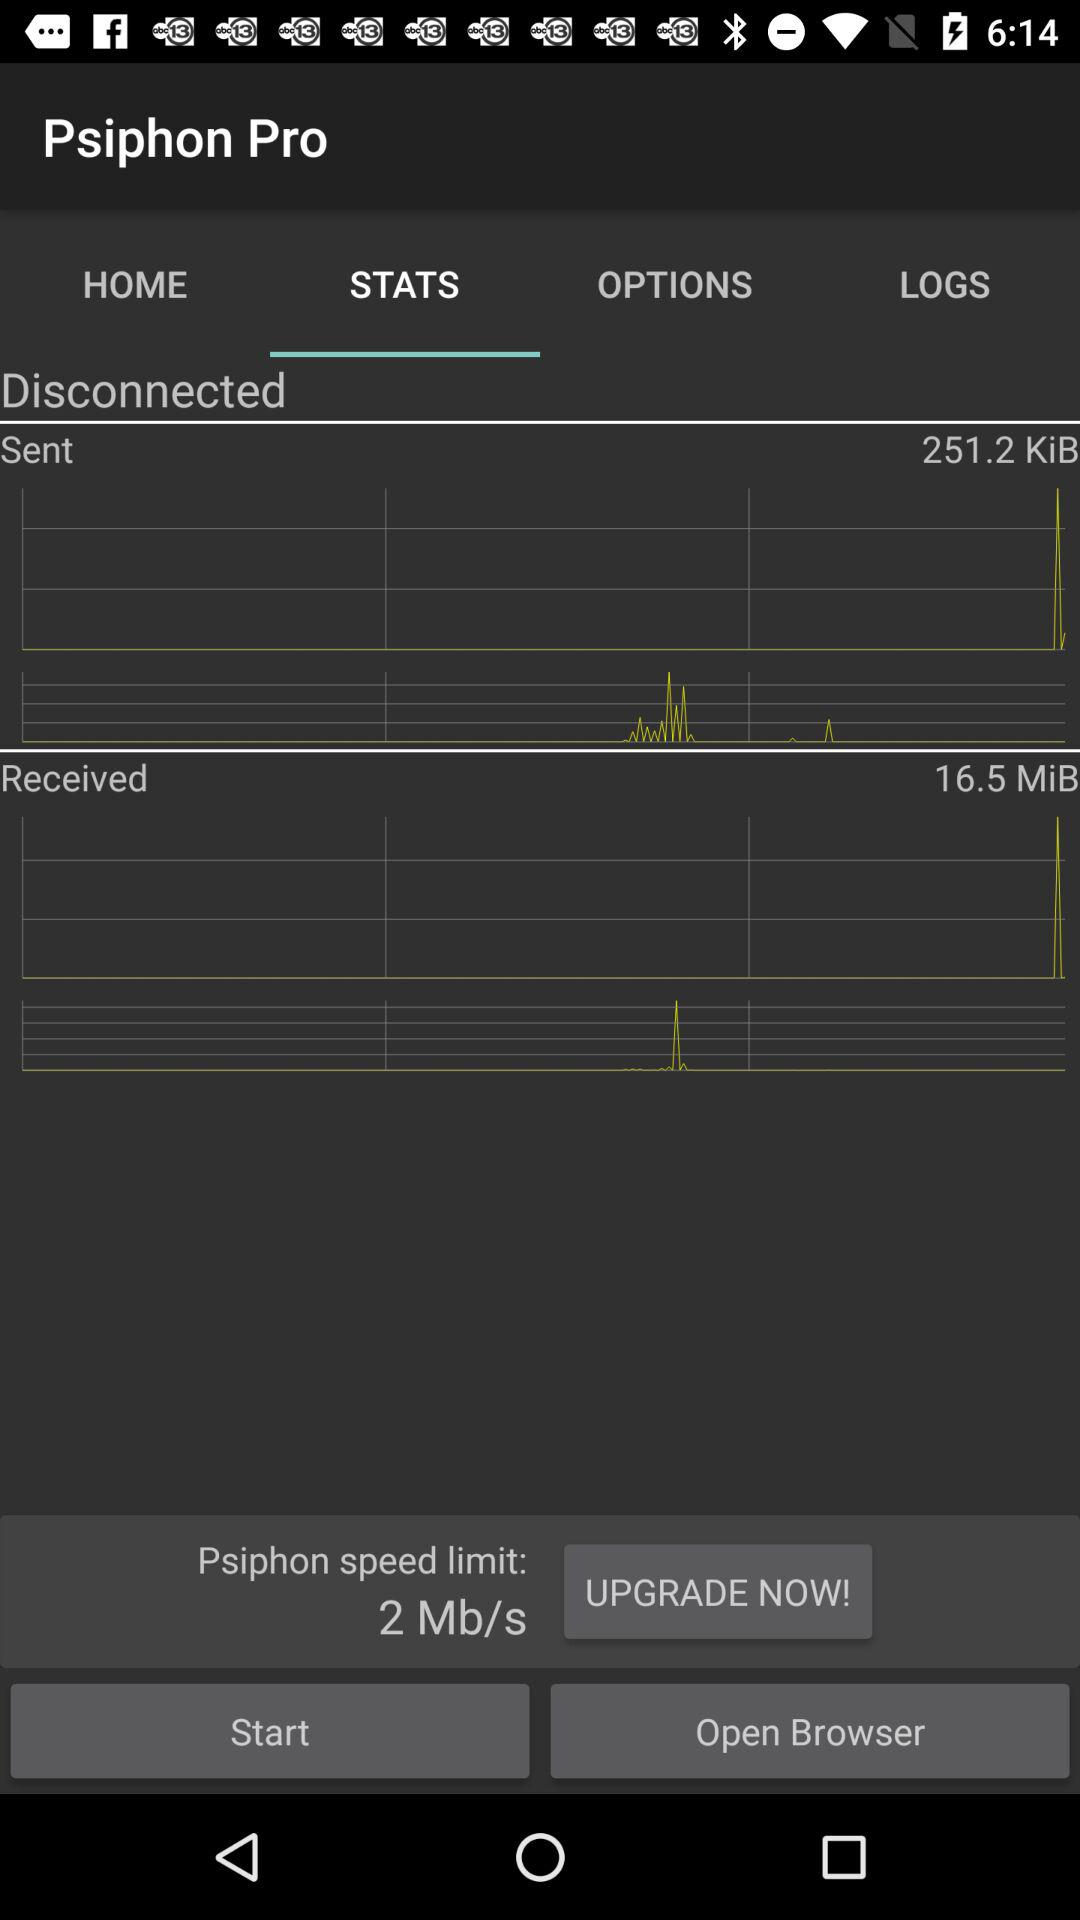What is the application name?
Answer the question using a single word or phrase. The application name is "Psiphon Pro" 